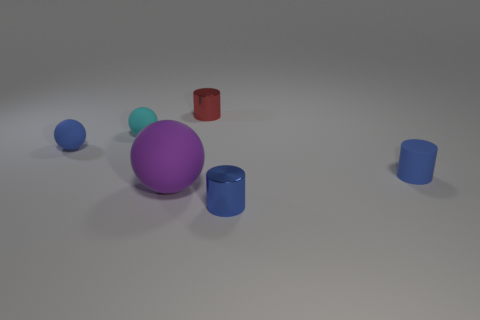Add 3 big purple objects. How many objects exist? 9 Subtract 0 red blocks. How many objects are left? 6 Subtract all matte objects. Subtract all cyan matte spheres. How many objects are left? 1 Add 1 purple spheres. How many purple spheres are left? 2 Add 3 red metallic cylinders. How many red metallic cylinders exist? 4 